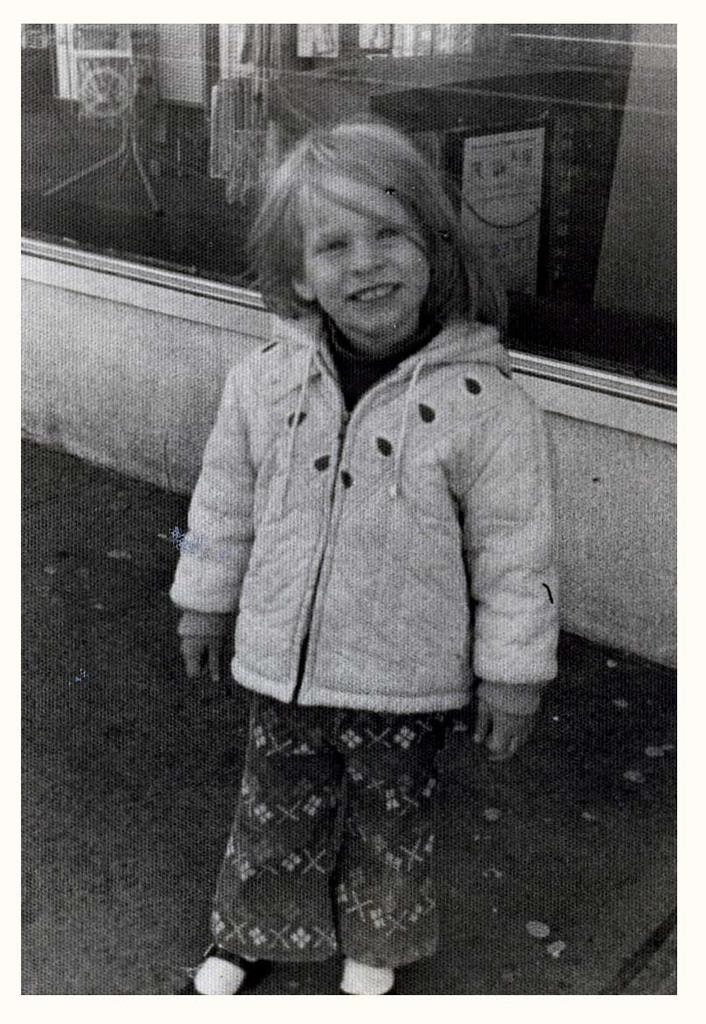What is the color scheme of the image? The image is black and white. What can be seen in the image? There is a child in the image. Where is the child located in the image? The child is standing on the floor. What type of band is playing in the background of the image? There is no band present in the image; it is a black and white image of a child standing on the floor. 